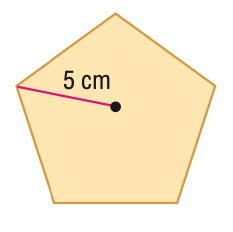Question: Find the area of the regular polygon. Round to the nearest tenth.
Choices:
A. 11.9
B. 29.7
C. 59.4
D. 118.9
Answer with the letter. Answer: C 